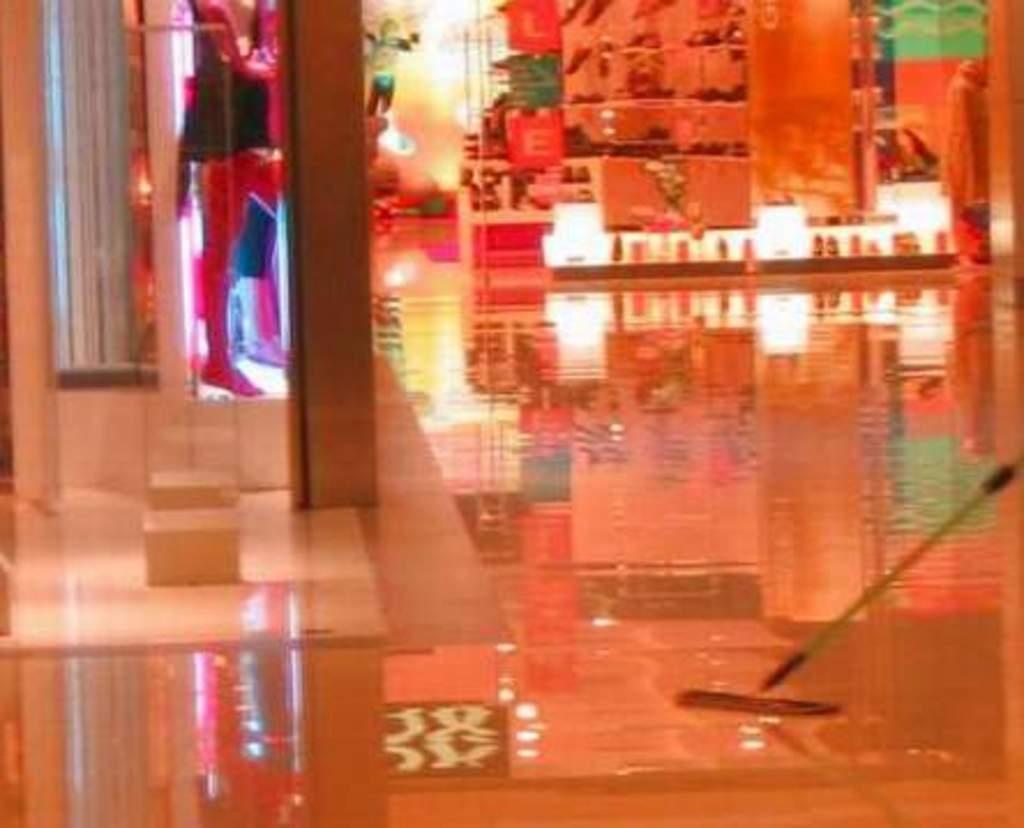Could you give a brief overview of what you see in this image? In this image, we can see a floor and there are some shops. 